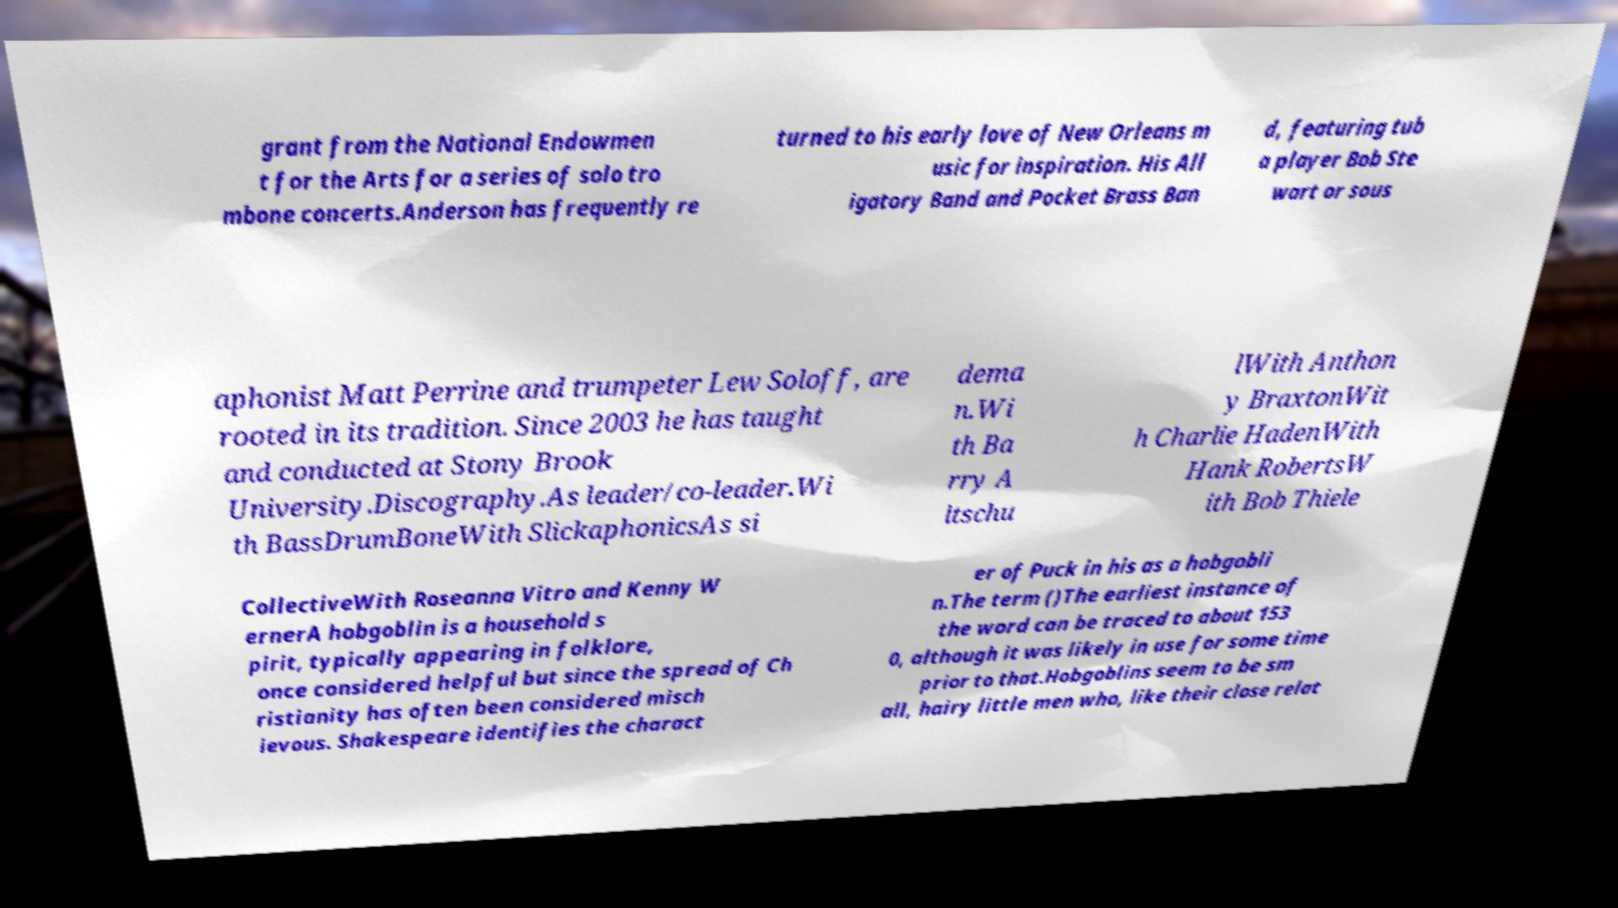Can you read and provide the text displayed in the image?This photo seems to have some interesting text. Can you extract and type it out for me? grant from the National Endowmen t for the Arts for a series of solo tro mbone concerts.Anderson has frequently re turned to his early love of New Orleans m usic for inspiration. His All igatory Band and Pocket Brass Ban d, featuring tub a player Bob Ste wart or sous aphonist Matt Perrine and trumpeter Lew Soloff, are rooted in its tradition. Since 2003 he has taught and conducted at Stony Brook University.Discography.As leader/co-leader.Wi th BassDrumBoneWith SlickaphonicsAs si dema n.Wi th Ba rry A ltschu lWith Anthon y BraxtonWit h Charlie HadenWith Hank RobertsW ith Bob Thiele CollectiveWith Roseanna Vitro and Kenny W ernerA hobgoblin is a household s pirit, typically appearing in folklore, once considered helpful but since the spread of Ch ristianity has often been considered misch ievous. Shakespeare identifies the charact er of Puck in his as a hobgobli n.The term ()The earliest instance of the word can be traced to about 153 0, although it was likely in use for some time prior to that.Hobgoblins seem to be sm all, hairy little men who, like their close relat 